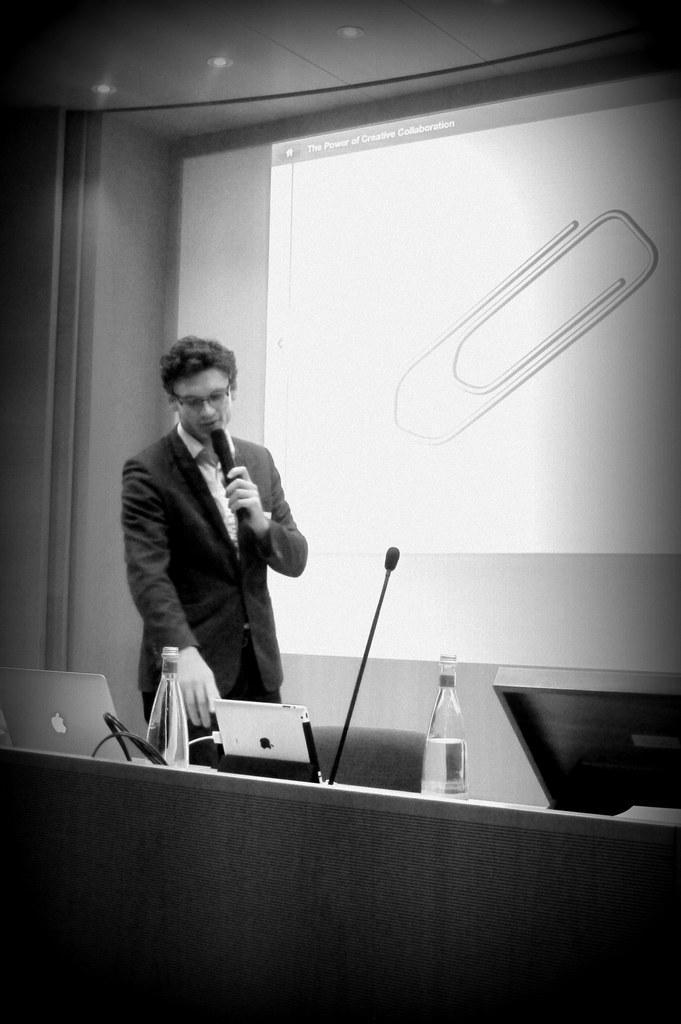Could you give a brief overview of what you see in this image? In this image we can see a man a holding a mic in his hands. There are laptops, water bottle and mic on the table. In the background we can see a projector screen. 